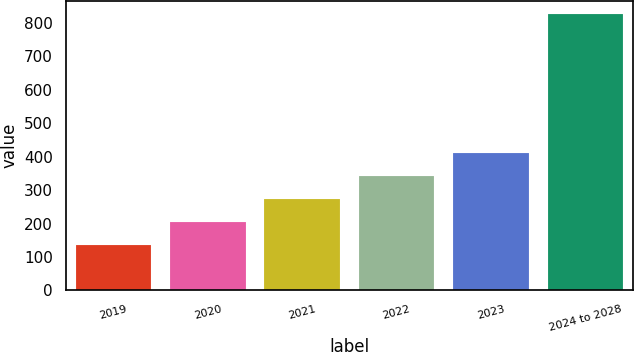Convert chart to OTSL. <chart><loc_0><loc_0><loc_500><loc_500><bar_chart><fcel>2019<fcel>2020<fcel>2021<fcel>2022<fcel>2023<fcel>2024 to 2028<nl><fcel>136<fcel>205<fcel>274<fcel>343<fcel>412<fcel>826<nl></chart> 